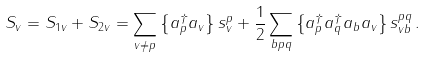<formula> <loc_0><loc_0><loc_500><loc_500>S _ { v } = S _ { 1 v } + S _ { 2 v } = \sum _ { v \neq p } \left \{ a _ { p } ^ { \dagger } a _ { v } \right \} s _ { v } ^ { p } + \frac { 1 } { 2 } \sum _ { b p q } \left \{ a _ { p } ^ { \dagger } a _ { q } ^ { \dagger } a _ { b } a _ { v } \right \} s _ { v b } ^ { p q } \, .</formula> 